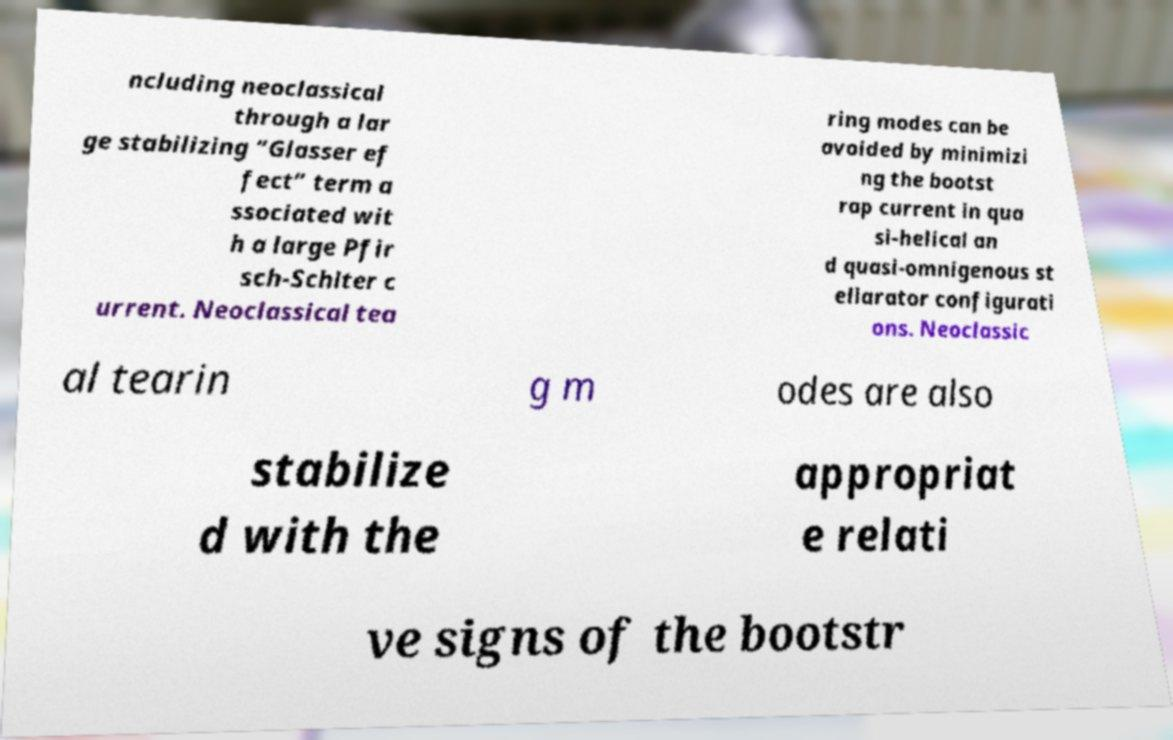Please read and relay the text visible in this image. What does it say? ncluding neoclassical through a lar ge stabilizing “Glasser ef fect” term a ssociated wit h a large Pfir sch-Schlter c urrent. Neoclassical tea ring modes can be avoided by minimizi ng the bootst rap current in qua si-helical an d quasi-omnigenous st ellarator configurati ons. Neoclassic al tearin g m odes are also stabilize d with the appropriat e relati ve signs of the bootstr 